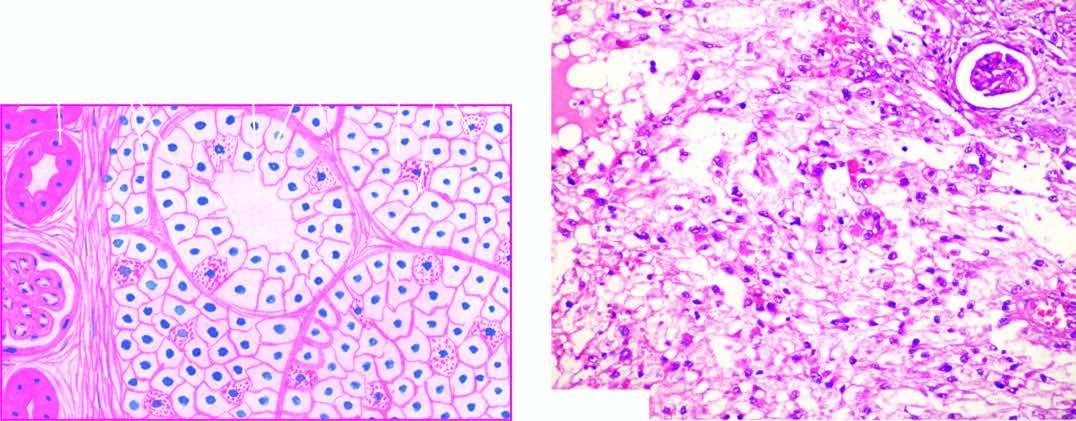does the tumour show solid masses and acini of uniform-appearing tumour cells?
Answer the question using a single word or phrase. Yes 